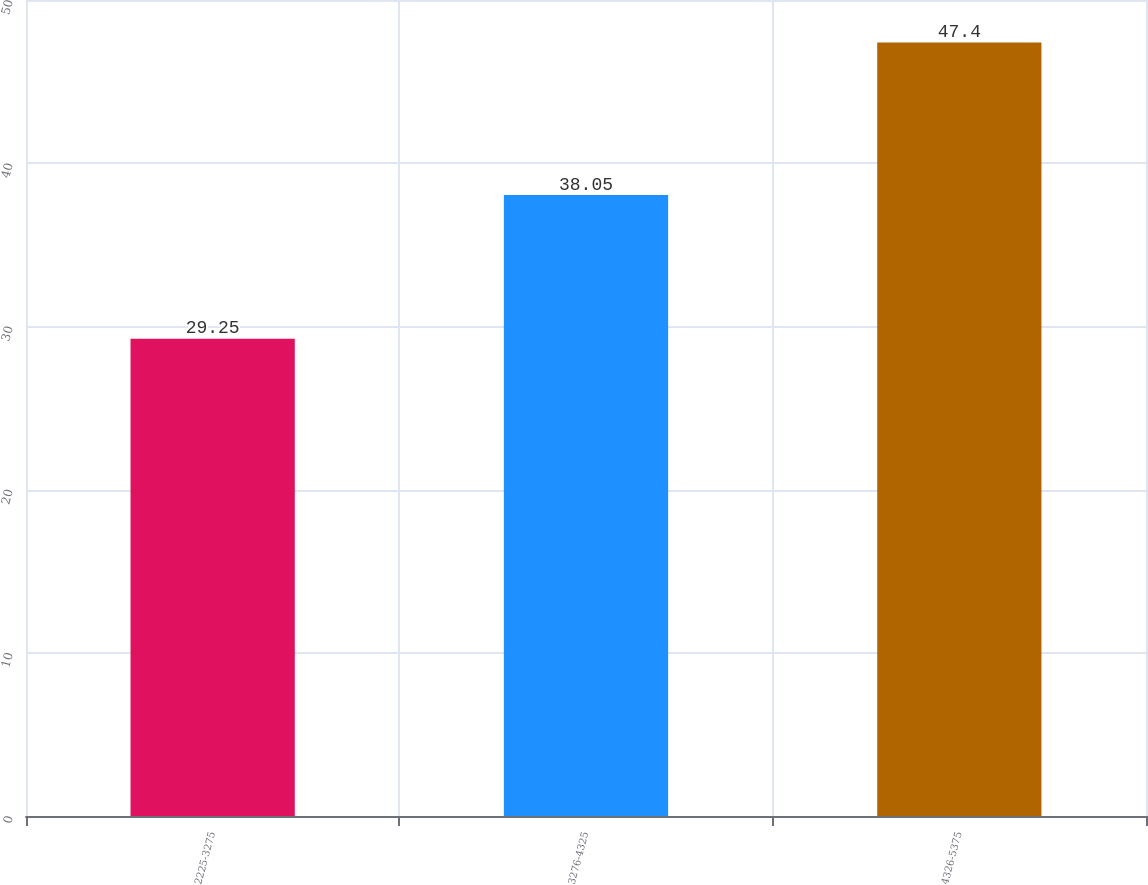Convert chart. <chart><loc_0><loc_0><loc_500><loc_500><bar_chart><fcel>2225-3275<fcel>3276-4325<fcel>4326-5375<nl><fcel>29.25<fcel>38.05<fcel>47.4<nl></chart> 